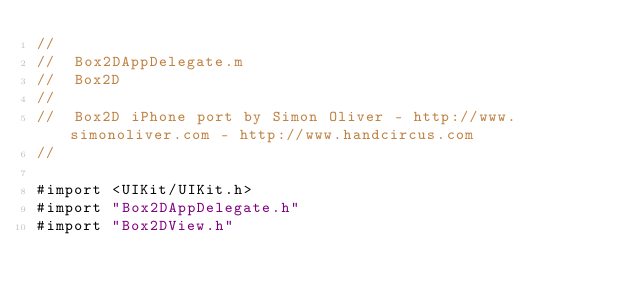Convert code to text. <code><loc_0><loc_0><loc_500><loc_500><_ObjectiveC_>//
//  Box2DAppDelegate.m
//  Box2D
//
//  Box2D iPhone port by Simon Oliver - http://www.simonoliver.com - http://www.handcircus.com
//

#import <UIKit/UIKit.h>
#import "Box2DAppDelegate.h"
#import "Box2DView.h"
</code> 